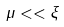<formula> <loc_0><loc_0><loc_500><loc_500>\mu < < \xi</formula> 